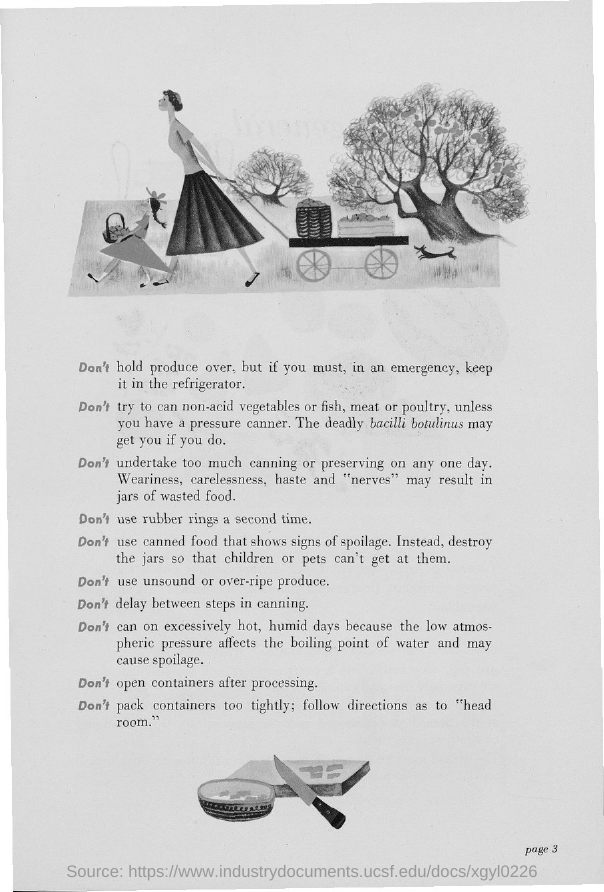What is the page number?
Make the answer very short. Page 3. 